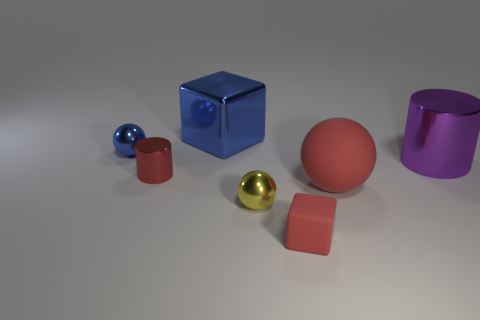Add 2 large yellow objects. How many objects exist? 9 Subtract all cubes. How many objects are left? 5 Subtract all small cyan metal things. Subtract all purple shiny things. How many objects are left? 6 Add 2 large purple things. How many large purple things are left? 3 Add 4 large red things. How many large red things exist? 5 Subtract 0 blue cylinders. How many objects are left? 7 